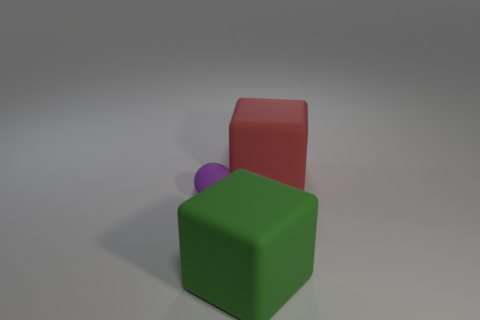The small sphere is what color?
Give a very brief answer. Purple. What number of other things are there of the same size as the ball?
Your answer should be very brief. 0. What material is the object that is both behind the large green thing and on the right side of the matte sphere?
Your answer should be very brief. Rubber. Is the size of the object behind the sphere the same as the tiny matte object?
Give a very brief answer. No. What number of matte things are both behind the big green matte object and to the right of the tiny thing?
Provide a succinct answer. 1. What number of small purple objects are right of the cube right of the big rubber block that is to the left of the red block?
Offer a very short reply. 0. What shape is the red thing?
Offer a very short reply. Cube. How many big green cubes have the same material as the tiny thing?
Ensure brevity in your answer.  1. What color is the big cube that is the same material as the large green object?
Offer a terse response. Red. There is a green matte cube; is its size the same as the rubber thing behind the small sphere?
Your answer should be compact. Yes. 